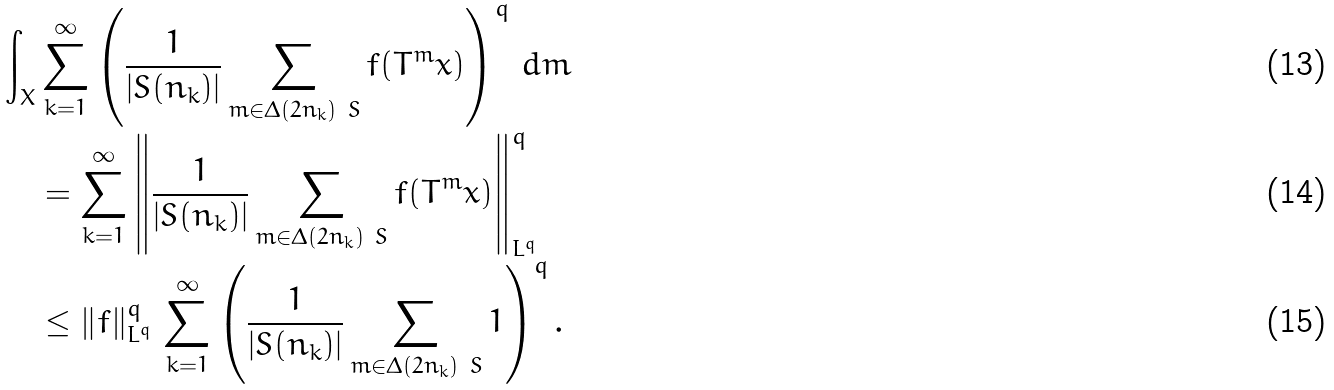Convert formula to latex. <formula><loc_0><loc_0><loc_500><loc_500>\int _ { X } & \sum _ { k = 1 } ^ { \infty } \left ( \frac { 1 } { | S ( n _ { k } ) | } \sum _ { m \in \Delta ( 2 n _ { k } ) \ S } f ( T ^ { m } x ) \right ) ^ { q } \, d m \\ & = \sum _ { k = 1 } ^ { \infty } \left \| \frac { 1 } { | S ( n _ { k } ) | } \sum _ { m \in \Delta ( 2 n _ { k } ) \ S } f ( T ^ { m } x ) \right \| _ { L ^ { q } } ^ { q } \\ & \leq \left \| f \right \| _ { L ^ { q } } ^ { q } \, \sum _ { k = 1 } ^ { \infty } \left ( \frac { 1 } { | S ( n _ { k } ) | } \sum _ { m \in \Delta ( 2 n _ { k } ) \ S } 1 \right ) ^ { q } .</formula> 